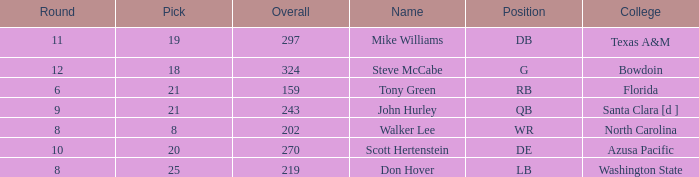Which college has a pick less than 25, an overall greater than 159, a round less than 10, and wr as the position? North Carolina. 